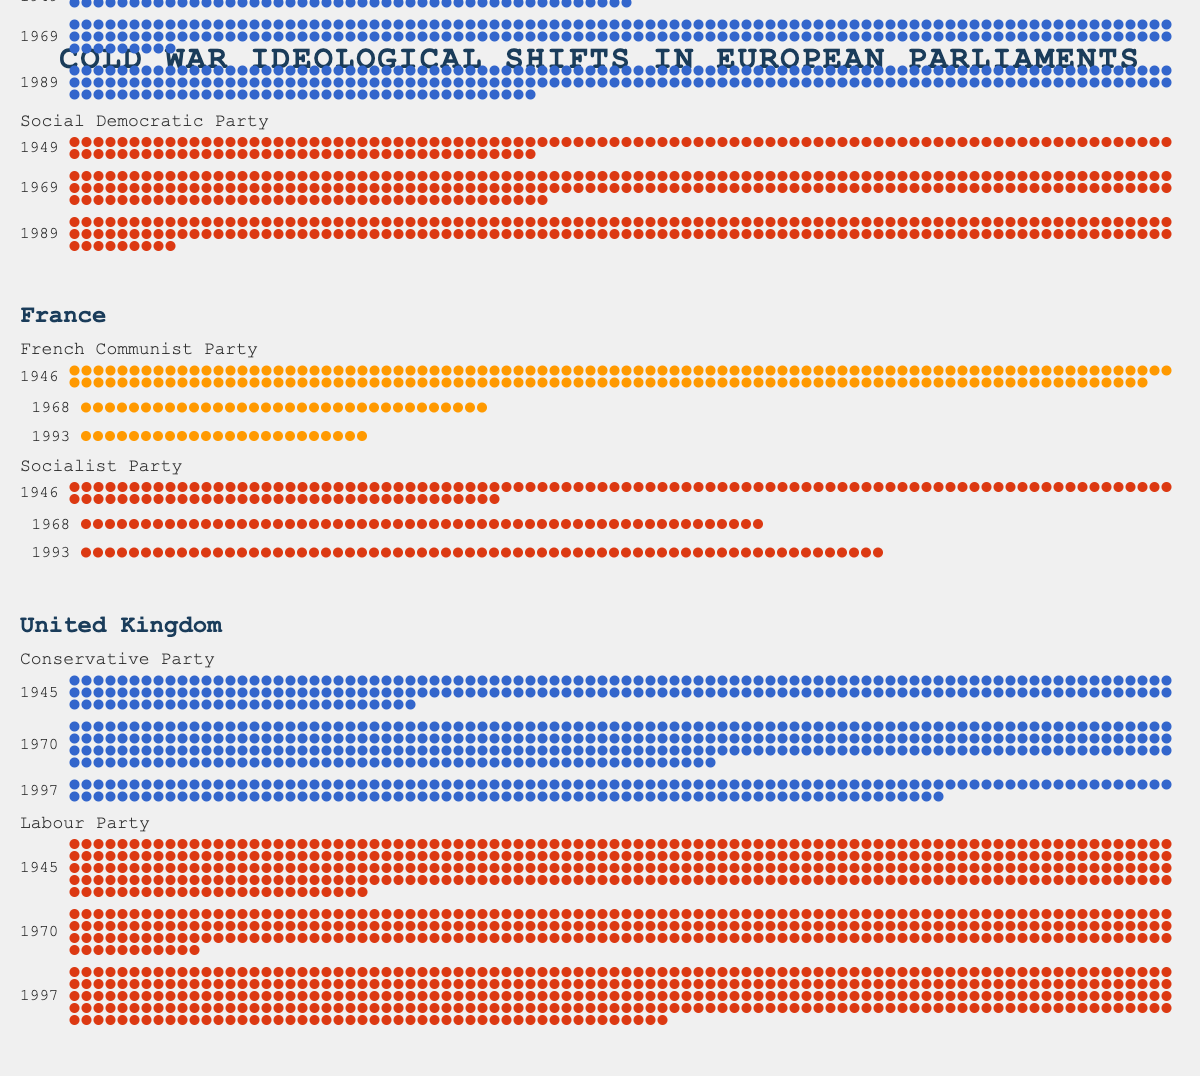What is the ideology of the Christian Democratic Union in West Germany? To find the ideology of the Christian Democratic Union, look for the party name under West Germany and read its corresponding ideology.
Answer: Center-right Which party had the most significant increase in seats in the United Kingdom between 1945 and 1997? Compare the number of seats in 1945 and 1997 for each party in the United Kingdom. The Labour Party had 393 seats in 1945 and 418 seats in 1997, showing an increase. The Conservative Party had 213 seats in 1945 and 165 seats in 1997, showing a decrease.
Answer: Labour Party How many total seats did the French Communist Party have in 1946, 1968, and 1993? Add the number of seats the French Communist Party had in 1946 (182), 1968 (34), and 1993 (24). The total is 182 + 34 + 24 = 240 seats.
Answer: 240 seats Which party had the highest number of seats in West Germany in 1989? Check the number of seats for each party in West Germany in 1989. The Christian Democratic Union had 223 seats, and the Social Democratic Party had 193 seats. The higher number of seats is 223.
Answer: Christian Democratic Union Compare the number of seats of the Conservative Party in 1970 and 1997 in the United Kingdom. Calculate the difference. Subtract the number of seats in 1997 (165) from the number of seats in 1970 (330). The difference is 330 - 165 = 165 seats.
Answer: 165 seats Which party in France saw a decline in seats from 1946 to 1993? Compare the number of seats in 1946 and 1993 for each party in France. The French Communist Party saw a decline from 182 seats in 1946 to 24 seats in 1993. The Socialist Party had 128 seats in 1946 and 67 seats in 1993, showing a lesser decline.
Answer: French Communist Party How did the number of seats for the Social Democratic Party in West Germany change from 1949 to 1969 to 1989? Track the number of seats for the Social Democratic Party in 1949 (131), 1969 (224), and 1989 (193). The number of seats increased from 131 to 224 between 1949 and 1969 but decreased to 193 by 1989.
Answer: Increased, then decreased What is the color used to represent Center-left ideological parties? Identify the color used for the labels of Center-left parties in the plot. The Center-left, represented by the Social Democratic Party in West Germany, the Socialist Party in France, and the Labour Party in the UK, uses red.
Answer: Red Which countries have Far-left parties, and what are they? Check for Far-left parties in the list of countries. Only France has a Far-left party, which is the French Communist Party.
Answer: France, French Communist Party 